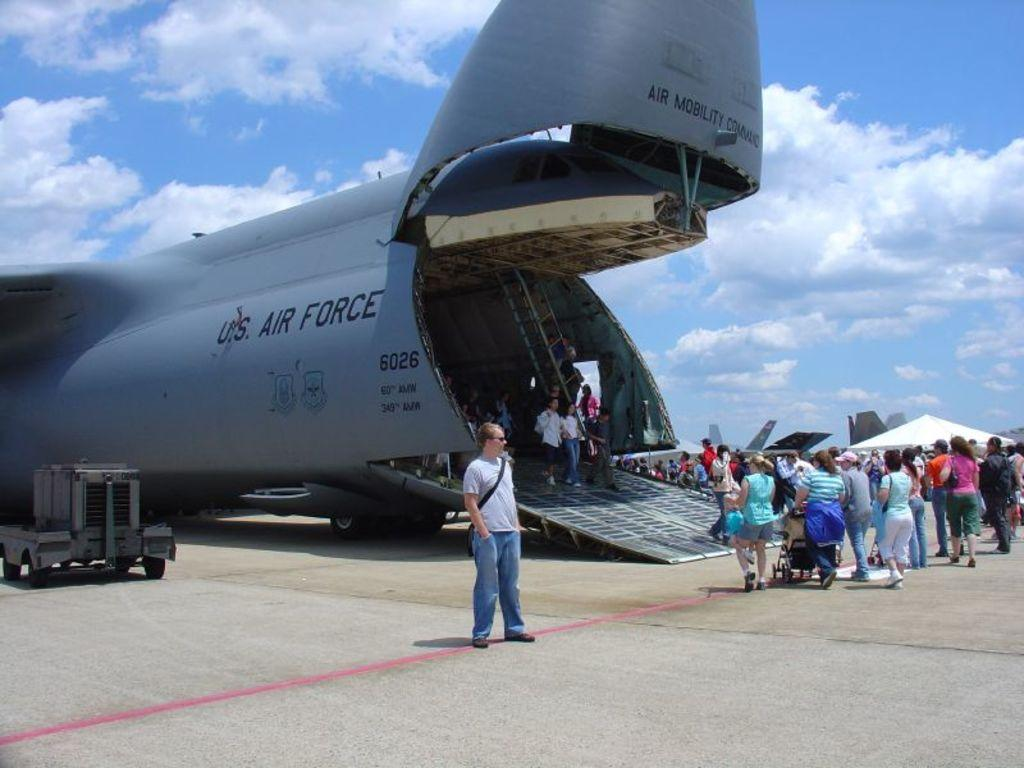Provide a one-sentence caption for the provided image. People are surrounding a US Air Force plane. 